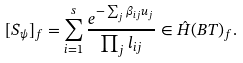<formula> <loc_0><loc_0><loc_500><loc_500>[ S _ { \psi } ] _ { f } = \sum _ { i = 1 } ^ { s } \frac { e ^ { - \sum _ { j } \beta _ { i j } u _ { j } } } { \prod _ { j } l _ { i j } } \in \hat { H } ( B T ) _ { f } .</formula> 